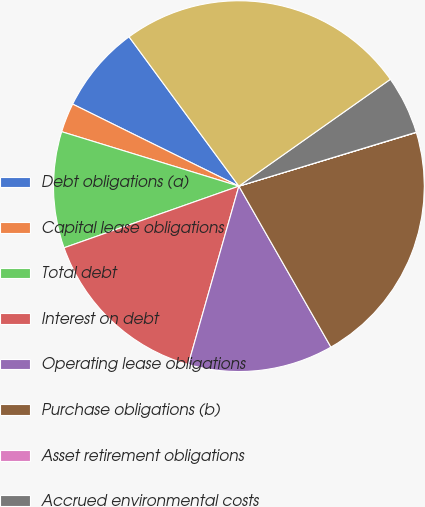<chart> <loc_0><loc_0><loc_500><loc_500><pie_chart><fcel>Debt obligations (a)<fcel>Capital lease obligations<fcel>Total debt<fcel>Interest on debt<fcel>Operating lease obligations<fcel>Purchase obligations (b)<fcel>Asset retirement obligations<fcel>Accrued environmental costs<fcel>Total<nl><fcel>7.61%<fcel>2.55%<fcel>10.14%<fcel>15.2%<fcel>12.67%<fcel>21.41%<fcel>0.02%<fcel>5.08%<fcel>25.31%<nl></chart> 